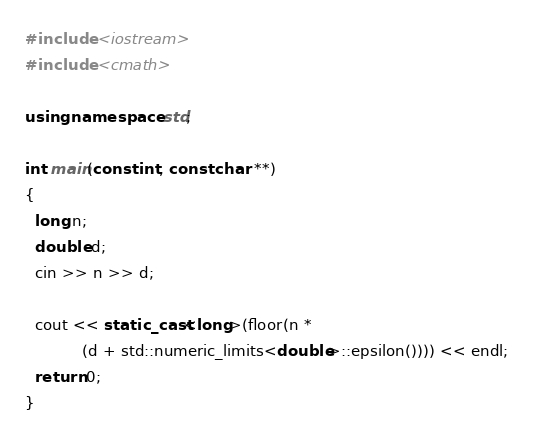Convert code to text. <code><loc_0><loc_0><loc_500><loc_500><_C++_>#include <iostream>
#include <cmath>

using namespace std;

int main(const int, const char **)
{
  long n;
  double d;
  cin >> n >> d;

  cout << static_cast<long>(floor(n *
            (d + std::numeric_limits<double>::epsilon()))) << endl;
  return 0;
}</code> 